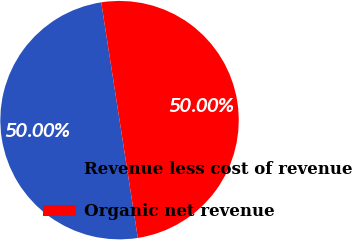<chart> <loc_0><loc_0><loc_500><loc_500><pie_chart><fcel>Revenue less cost of revenue<fcel>Organic net revenue<nl><fcel>50.0%<fcel>50.0%<nl></chart> 